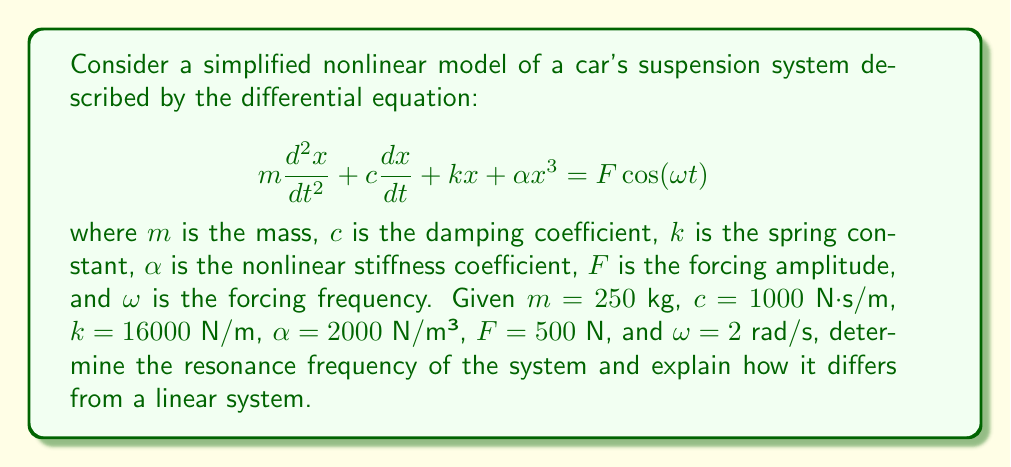Could you help me with this problem? To solve this problem, we'll follow these steps:

1) First, recall that for a linear system (without the $\alpha x^3$ term), the natural frequency would be:

   $$\omega_n = \sqrt{\frac{k}{m}}$$

2) For our given values:

   $$\omega_n = \sqrt{\frac{16000}{250}} = 8 \text{ rad/s}$$

3) However, due to the nonlinear term $\alpha x^3$, the resonance frequency will be different. In nonlinear systems, the resonance frequency depends on the amplitude of oscillation.

4) For small oscillations, the system behaves almost linearly, and the resonance frequency is close to $\omega_n$. As the amplitude increases, the effective stiffness increases due to the $\alpha x^3$ term.

5) The effective stiffness can be approximated as $k_{eff} = k + 3\alpha A^2$, where $A$ is the amplitude of oscillation.

6) This leads to an amplitude-dependent resonance frequency:

   $$\omega_r \approx \sqrt{\frac{k_{eff}}{m}} = \sqrt{\frac{k + 3\alpha A^2}{m}}$$

7) As $A$ increases, $\omega_r$ increases, causing the resonance peak to lean towards higher frequencies. This phenomenon is known as the "hardening spring effect."

8) The exact resonance frequency depends on the steady-state amplitude, which is determined by the balance of energy input (forcing) and dissipation (damping).

9) In practice, for a given forcing amplitude $F$, the resonance frequency would be found by solving the nonlinear equation of motion numerically or using perturbation methods.

10) The presence of the nonlinear term also introduces phenomena not seen in linear systems, such as multiple stable solutions, jump phenomena, and chaotic behavior under certain conditions.
Answer: The resonance frequency is amplitude-dependent, approximated by $\omega_r \approx \sqrt{\frac{k + 3\alpha A^2}{m}}$, which is higher than the linear natural frequency of 8 rad/s and increases with oscillation amplitude. 